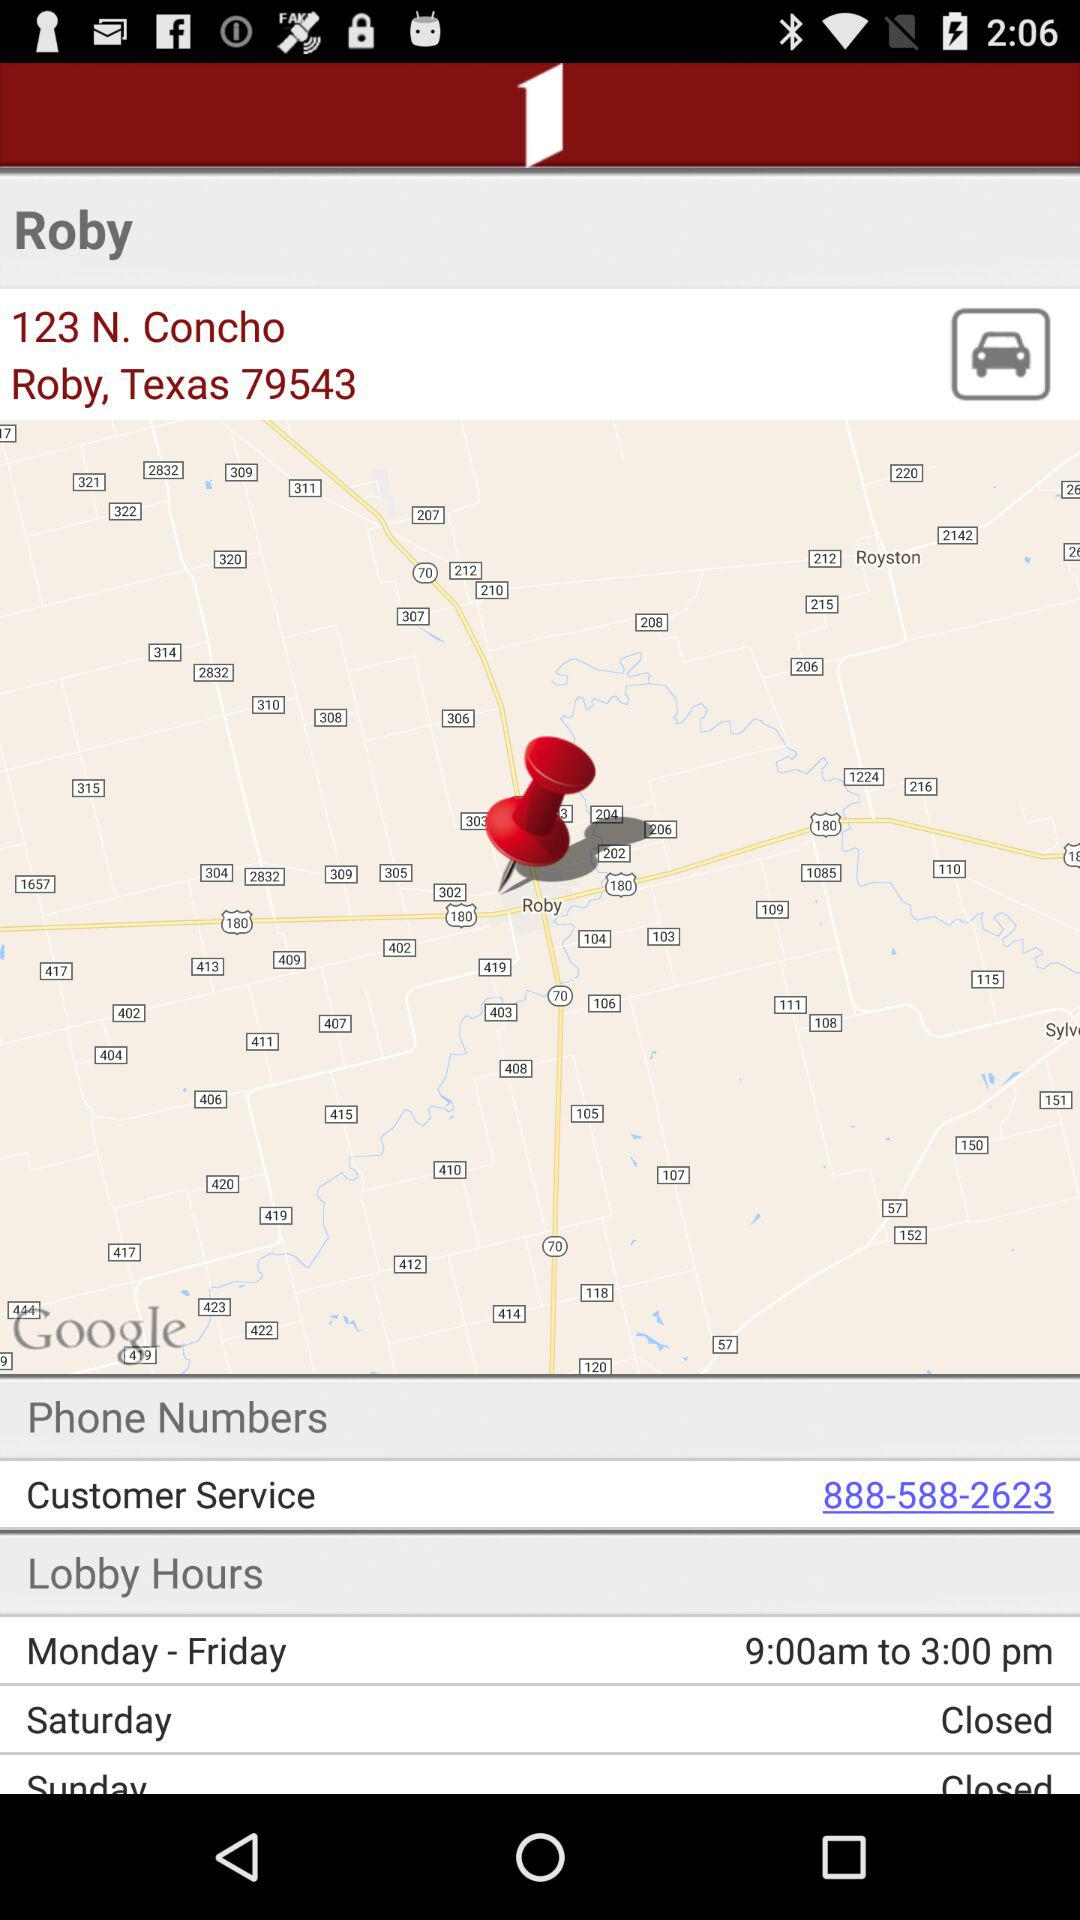What is the customer service number? The customer service number is 888-588-2623. 